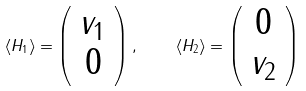Convert formula to latex. <formula><loc_0><loc_0><loc_500><loc_500>\langle H _ { 1 } \rangle = \left ( \begin{array} { c } v _ { 1 } \\ 0 \end{array} \right ) , \quad \langle H _ { 2 } \rangle = \left ( \begin{array} { c } 0 \\ v _ { 2 } \end{array} \right )</formula> 